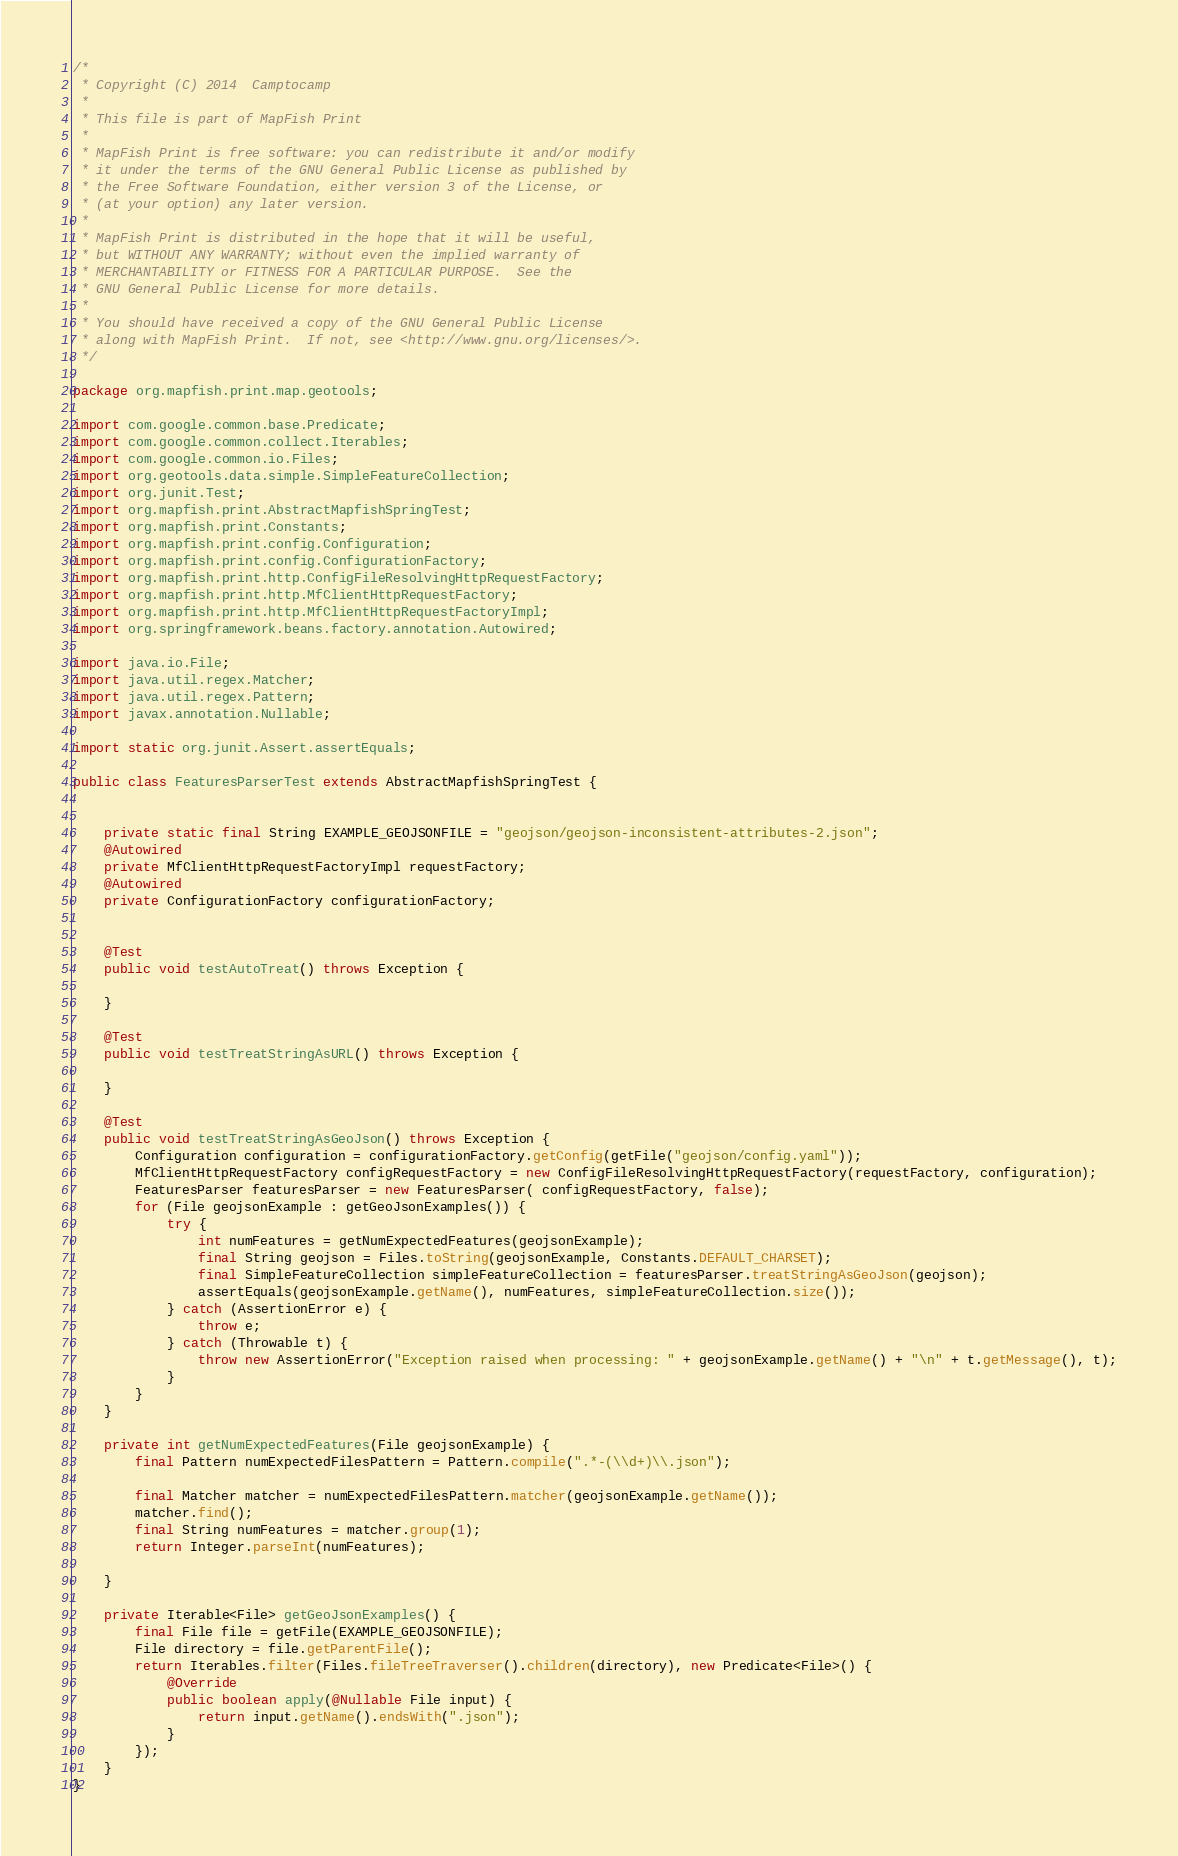Convert code to text. <code><loc_0><loc_0><loc_500><loc_500><_Java_>/*
 * Copyright (C) 2014  Camptocamp
 *
 * This file is part of MapFish Print
 *
 * MapFish Print is free software: you can redistribute it and/or modify
 * it under the terms of the GNU General Public License as published by
 * the Free Software Foundation, either version 3 of the License, or
 * (at your option) any later version.
 *
 * MapFish Print is distributed in the hope that it will be useful,
 * but WITHOUT ANY WARRANTY; without even the implied warranty of
 * MERCHANTABILITY or FITNESS FOR A PARTICULAR PURPOSE.  See the
 * GNU General Public License for more details.
 *
 * You should have received a copy of the GNU General Public License
 * along with MapFish Print.  If not, see <http://www.gnu.org/licenses/>.
 */

package org.mapfish.print.map.geotools;

import com.google.common.base.Predicate;
import com.google.common.collect.Iterables;
import com.google.common.io.Files;
import org.geotools.data.simple.SimpleFeatureCollection;
import org.junit.Test;
import org.mapfish.print.AbstractMapfishSpringTest;
import org.mapfish.print.Constants;
import org.mapfish.print.config.Configuration;
import org.mapfish.print.config.ConfigurationFactory;
import org.mapfish.print.http.ConfigFileResolvingHttpRequestFactory;
import org.mapfish.print.http.MfClientHttpRequestFactory;
import org.mapfish.print.http.MfClientHttpRequestFactoryImpl;
import org.springframework.beans.factory.annotation.Autowired;

import java.io.File;
import java.util.regex.Matcher;
import java.util.regex.Pattern;
import javax.annotation.Nullable;

import static org.junit.Assert.assertEquals;

public class FeaturesParserTest extends AbstractMapfishSpringTest {


    private static final String EXAMPLE_GEOJSONFILE = "geojson/geojson-inconsistent-attributes-2.json";
    @Autowired
    private MfClientHttpRequestFactoryImpl requestFactory;
    @Autowired
    private ConfigurationFactory configurationFactory;


    @Test
    public void testAutoTreat() throws Exception {

    }

    @Test
    public void testTreatStringAsURL() throws Exception {

    }

    @Test
    public void testTreatStringAsGeoJson() throws Exception {
        Configuration configuration = configurationFactory.getConfig(getFile("geojson/config.yaml"));
        MfClientHttpRequestFactory configRequestFactory = new ConfigFileResolvingHttpRequestFactory(requestFactory, configuration);
        FeaturesParser featuresParser = new FeaturesParser( configRequestFactory, false);
        for (File geojsonExample : getGeoJsonExamples()) {
            try {
                int numFeatures = getNumExpectedFeatures(geojsonExample);
                final String geojson = Files.toString(geojsonExample, Constants.DEFAULT_CHARSET);
                final SimpleFeatureCollection simpleFeatureCollection = featuresParser.treatStringAsGeoJson(geojson);
                assertEquals(geojsonExample.getName(), numFeatures, simpleFeatureCollection.size());
            } catch (AssertionError e) {
                throw e;
            } catch (Throwable t) {
                throw new AssertionError("Exception raised when processing: " + geojsonExample.getName() + "\n" + t.getMessage(), t);
            }
        }
    }

    private int getNumExpectedFeatures(File geojsonExample) {
        final Pattern numExpectedFilesPattern = Pattern.compile(".*-(\\d+)\\.json");

        final Matcher matcher = numExpectedFilesPattern.matcher(geojsonExample.getName());
        matcher.find();
        final String numFeatures = matcher.group(1);
        return Integer.parseInt(numFeatures);

    }

    private Iterable<File> getGeoJsonExamples() {
        final File file = getFile(EXAMPLE_GEOJSONFILE);
        File directory = file.getParentFile();
        return Iterables.filter(Files.fileTreeTraverser().children(directory), new Predicate<File>() {
            @Override
            public boolean apply(@Nullable File input) {
                return input.getName().endsWith(".json");
            }
        });
    }
}</code> 